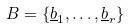<formula> <loc_0><loc_0><loc_500><loc_500>B = \{ \underline { b } _ { 1 } , \dots , \underline { b } _ { r } \}</formula> 